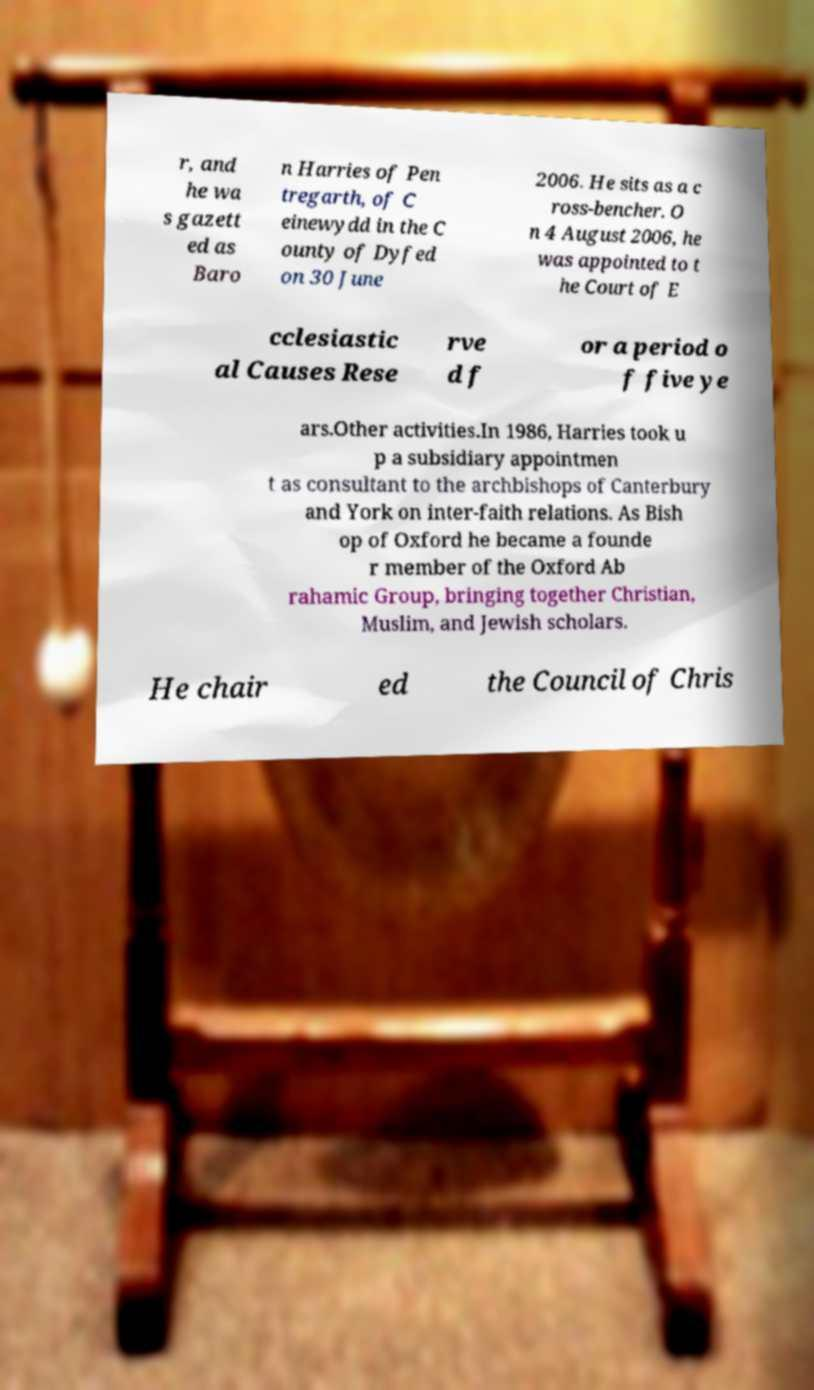Can you accurately transcribe the text from the provided image for me? r, and he wa s gazett ed as Baro n Harries of Pen tregarth, of C einewydd in the C ounty of Dyfed on 30 June 2006. He sits as a c ross-bencher. O n 4 August 2006, he was appointed to t he Court of E cclesiastic al Causes Rese rve d f or a period o f five ye ars.Other activities.In 1986, Harries took u p a subsidiary appointmen t as consultant to the archbishops of Canterbury and York on inter-faith relations. As Bish op of Oxford he became a founde r member of the Oxford Ab rahamic Group, bringing together Christian, Muslim, and Jewish scholars. He chair ed the Council of Chris 